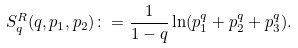Convert formula to latex. <formula><loc_0><loc_0><loc_500><loc_500>S _ { q } ^ { R } ( q , p _ { 1 } , p _ { 2 } ) \colon = \frac { 1 } { 1 - q } \ln ( p _ { 1 } ^ { q } + p _ { 2 } ^ { q } + p _ { 3 } ^ { q } ) .</formula> 